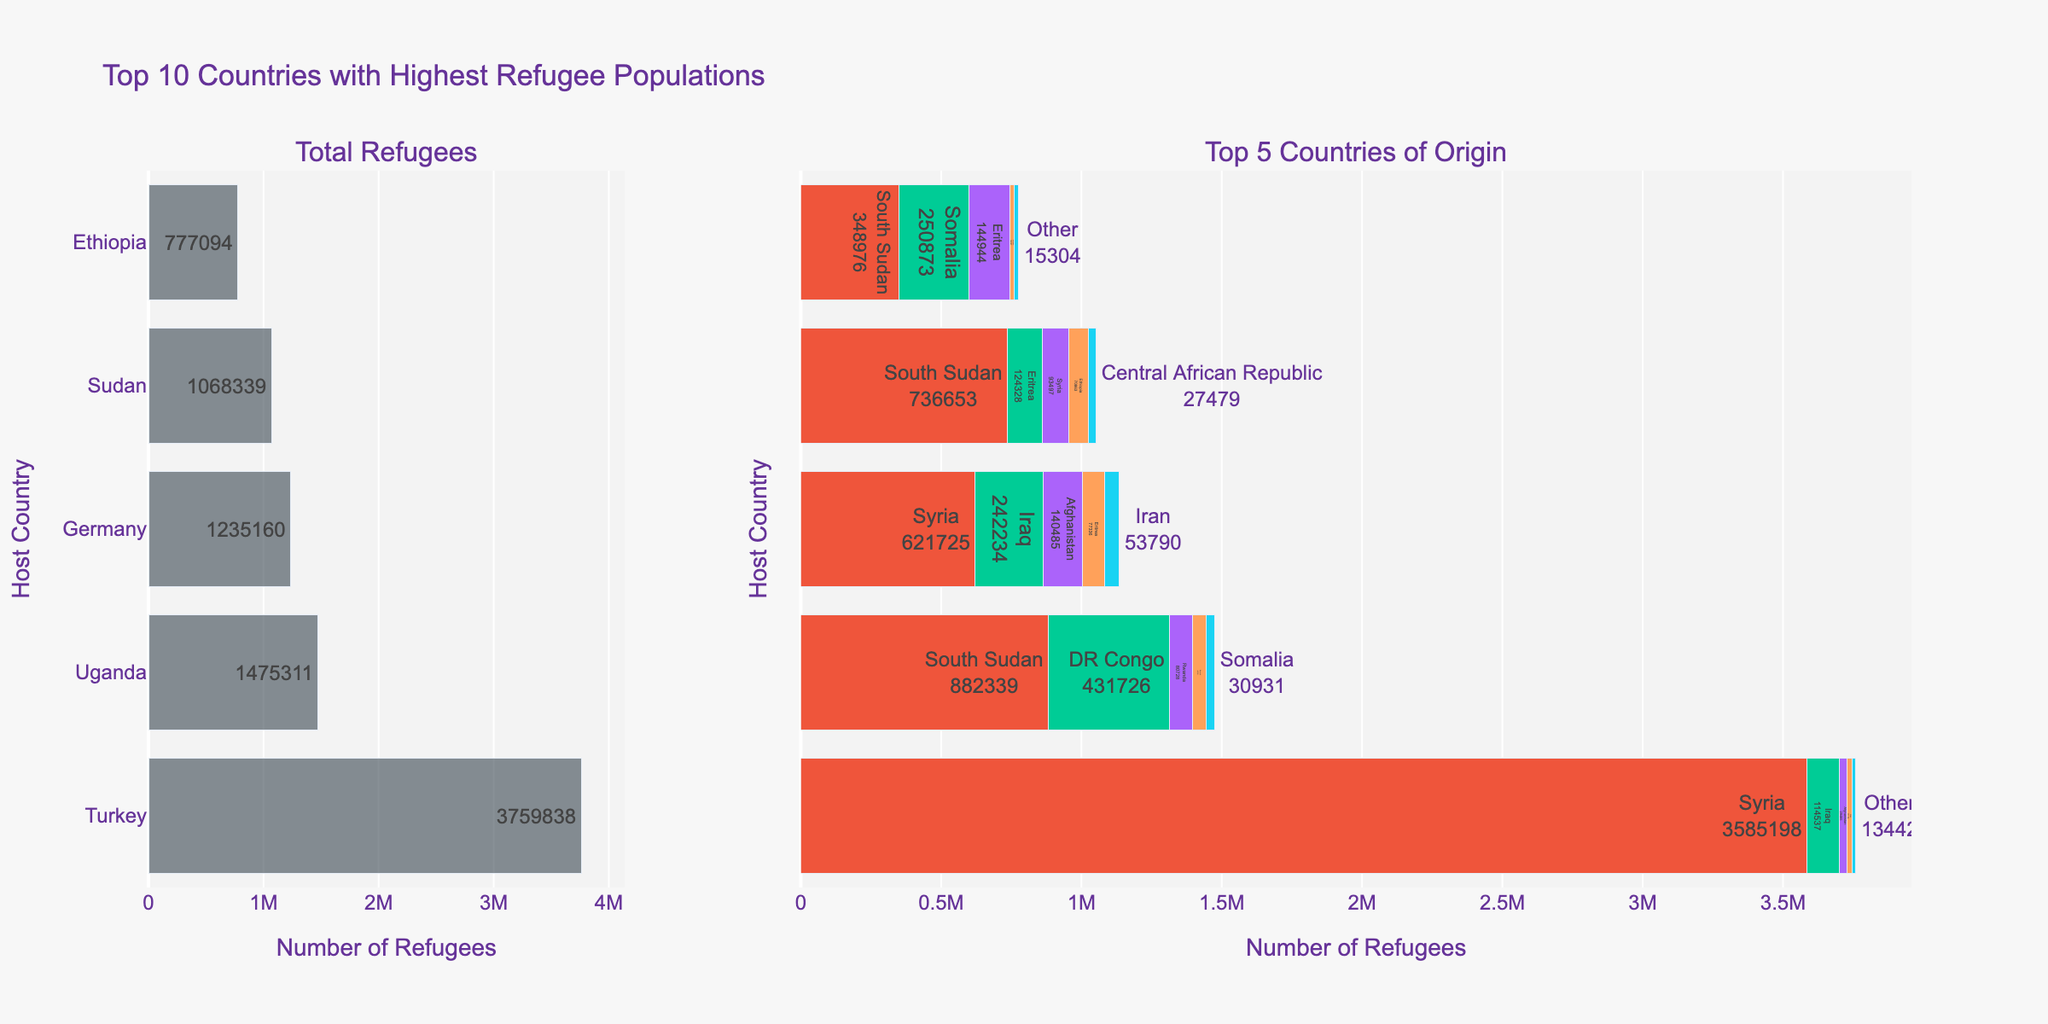Which country hosts the most refugees? By looking at the Total Refugees bar chart, Turkey has the longest bar indicating the highest number, followed by Uganda and Germany. The exact number next to Turkey's bar is 3,759,838.
Answer: Turkey Which country has more refugees from Syria, Germany or Sudan? From the stacked bar chart in the Top 5 Countries of Origin, we can see the sections labeled "Syria" for Germany and Sudan. The length of the bar for Germany originating from Syria is longer compared to Sudan. The exact figure shows Germany hosts 621,725 refugees from Syria, whereas Sudan hosts 93,497.
Answer: Germany Which origin country contributes the most refugees to Turkey? In the stacked bar section for Turkey in the Top 5 Countries of Origin chart, the largest segment is labeled "Syria: 3,585,198," indicating that Syria contributes the most refugees.
Answer: Syria Which host country has the smallest number of total refugees among the given countries? By comparing the lengths of the Total Refugees bars, Ethiopia has the shortest bar with the number next to it displaying 777,094, comparatively less than the other countries.
Answer: Ethiopia How many refugees from Eritrea are hosted together in Germany and Sudan? Germany hosts 77,336 refugees from Eritrea and Sudan hosts 124,328 refugees from Eritrea. Summing these up: 77,336 + 124,328 = 201,664.
Answer: 201,664 Compare the number of refugees from Afghanistan in Germany and Turkey. Which country hosts more and by how much? Germany hosts 140,485 refugees from Afghanistan, and Turkey hosts 29,485 refugees from Afghanistan. To find the difference: 140,485 - 29,485 = 111,000. Therefore, Germany hosts 111,000 more refugees from Afghanistan than Turkey.
Answer: Germany by 111,000 In the context of Uganda's refugee population, which origin country contributes the least refugees among the top 5 listed origins? In Uganda's stacked bar chart, the smallest segment is labeled "Somalia: 30,931," indicating Somalia contributes the least refugees among the top 5 origins listed.
Answer: Somalia What is the visual difference between the Total Refugees and Top 5 Countries of Origin charts? The Total Refugees chart shows a single horizontal bar for each country, indicating the total number of refugees hosted. The Top 5 Countries of Origin chart displays stacked horizontal bars for each country, showing the breakdown of refugees by their country of origin. This distinction allows us to see both the aggregate and the composition of refugee populations.
Answer: Single vs. stacked bars 